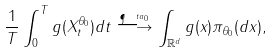<formula> <loc_0><loc_0><loc_500><loc_500>\frac { 1 } { T } \int _ { 0 } ^ { T } g ( X _ { t } ^ { \theta _ { 0 } } ) d t \overset { \P ^ { \ t a _ { 0 } } } { \longrightarrow } \int _ { \mathbb { R } ^ { d } } g ( x ) \pi _ { \theta _ { 0 } } ( d x ) ,</formula> 